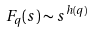Convert formula to latex. <formula><loc_0><loc_0><loc_500><loc_500>F _ { q } ( s ) \sim s ^ { h ( q ) }</formula> 